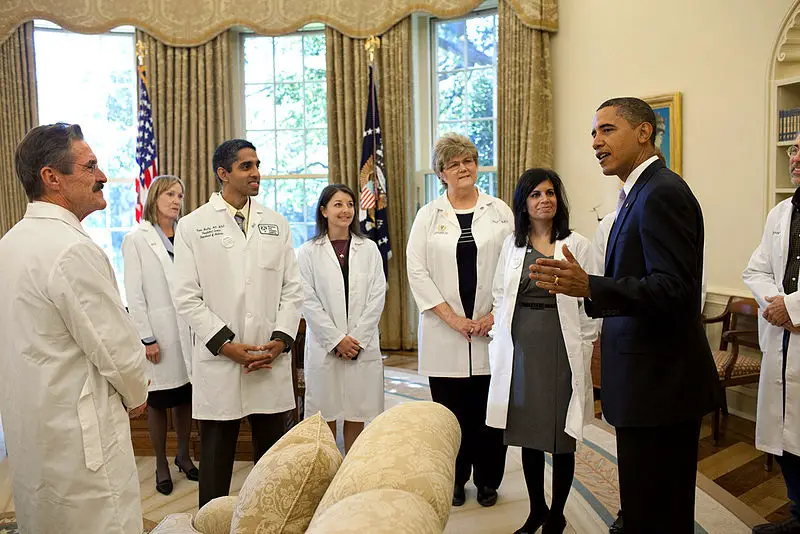Can you describe the significance of having such a meeting in this particular setting? Holding a meeting in this setting, which appears to be a high-ranking official's office or a government building, signifies the importance and gravity of the discussion. This choice of location underscores the commitment to addressing the discussed issues at the highest levels of governance. It also symbolizes the integration of expert advice from medical professionals into policymaking processes, ensuring that decisions are informed by scientific knowledge and data. Imagine if this meeting were set in a different era, such as the 1800s. How would the scene differ? In the 1800s, the scene would look quite different. The attire of the individuals would likely include formal suits, top hats, and cravats for men, and long dresses with bustles for women, rather than modern lab coats and business suits. The decor would be more elaborate, with heavy drapes, ornate furniture, and possibly oil lamps or early electric lighting, given the era. Instead of discussing modern healthcare issues, the focus might be on contagious diseases of that time, like tuberculosis or cholera, with public health discussions revolving around sanitation and disease prevention through emerging medical practices of the time. 